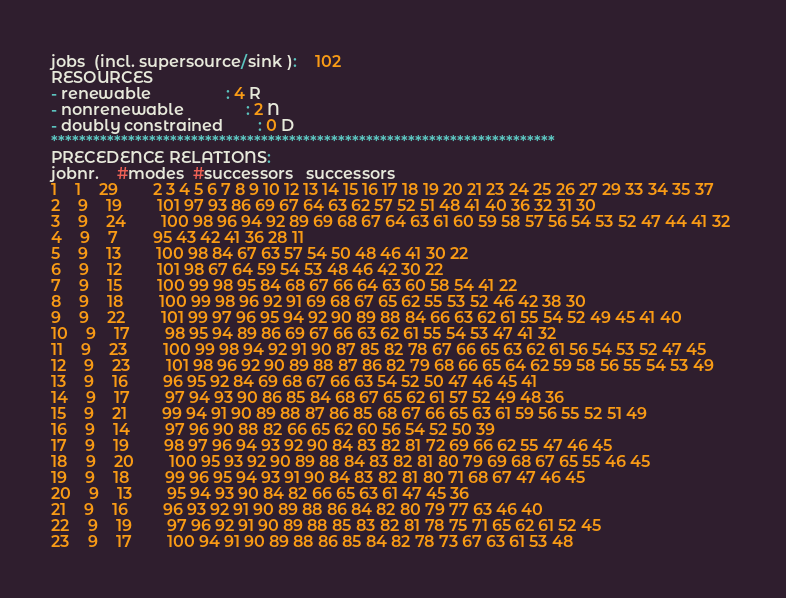<code> <loc_0><loc_0><loc_500><loc_500><_ObjectiveC_>jobs  (incl. supersource/sink ):	102
RESOURCES
- renewable                 : 4 R
- nonrenewable              : 2 N
- doubly constrained        : 0 D
************************************************************************
PRECEDENCE RELATIONS:
jobnr.    #modes  #successors   successors
1	1	29		2 3 4 5 6 7 8 9 10 12 13 14 15 16 17 18 19 20 21 23 24 25 26 27 29 33 34 35 37 
2	9	19		101 97 93 86 69 67 64 63 62 57 52 51 48 41 40 36 32 31 30 
3	9	24		100 98 96 94 92 89 69 68 67 64 63 61 60 59 58 57 56 54 53 52 47 44 41 32 
4	9	7		95 43 42 41 36 28 11 
5	9	13		100 98 84 67 63 57 54 50 48 46 41 30 22 
6	9	12		101 98 67 64 59 54 53 48 46 42 30 22 
7	9	15		100 99 98 95 84 68 67 66 64 63 60 58 54 41 22 
8	9	18		100 99 98 96 92 91 69 68 67 65 62 55 53 52 46 42 38 30 
9	9	22		101 99 97 96 95 94 92 90 89 88 84 66 63 62 61 55 54 52 49 45 41 40 
10	9	17		98 95 94 89 86 69 67 66 63 62 61 55 54 53 47 41 32 
11	9	23		100 99 98 94 92 91 90 87 85 82 78 67 66 65 63 62 61 56 54 53 52 47 45 
12	9	23		101 98 96 92 90 89 88 87 86 82 79 68 66 65 64 62 59 58 56 55 54 53 49 
13	9	16		96 95 92 84 69 68 67 66 63 54 52 50 47 46 45 41 
14	9	17		97 94 93 90 86 85 84 68 67 65 62 61 57 52 49 48 36 
15	9	21		99 94 91 90 89 88 87 86 85 68 67 66 65 63 61 59 56 55 52 51 49 
16	9	14		97 96 90 88 82 66 65 62 60 56 54 52 50 39 
17	9	19		98 97 96 94 93 92 90 84 83 82 81 72 69 66 62 55 47 46 45 
18	9	20		100 95 93 92 90 89 88 84 83 82 81 80 79 69 68 67 65 55 46 45 
19	9	18		99 96 95 94 93 91 90 84 83 82 81 80 71 68 67 47 46 45 
20	9	13		95 94 93 90 84 82 66 65 63 61 47 45 36 
21	9	16		96 93 92 91 90 89 88 86 84 82 80 79 77 63 46 40 
22	9	19		97 96 92 91 90 89 88 85 83 82 81 78 75 71 65 62 61 52 45 
23	9	17		100 94 91 90 89 88 86 85 84 82 78 73 67 63 61 53 48 </code> 